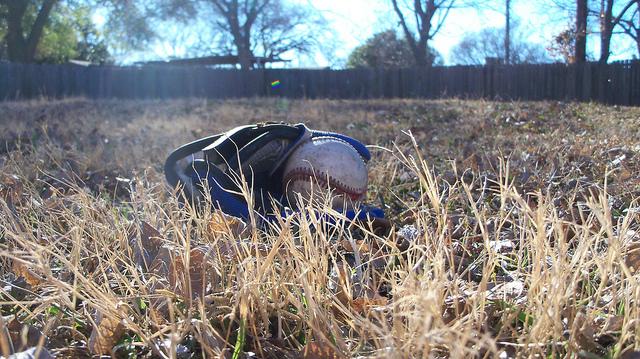What is the ball in?
Write a very short answer. Glove. Is the grass around the ball dead or alive?
Short answer required. Dead. Is the ball in the air?
Answer briefly. No. 